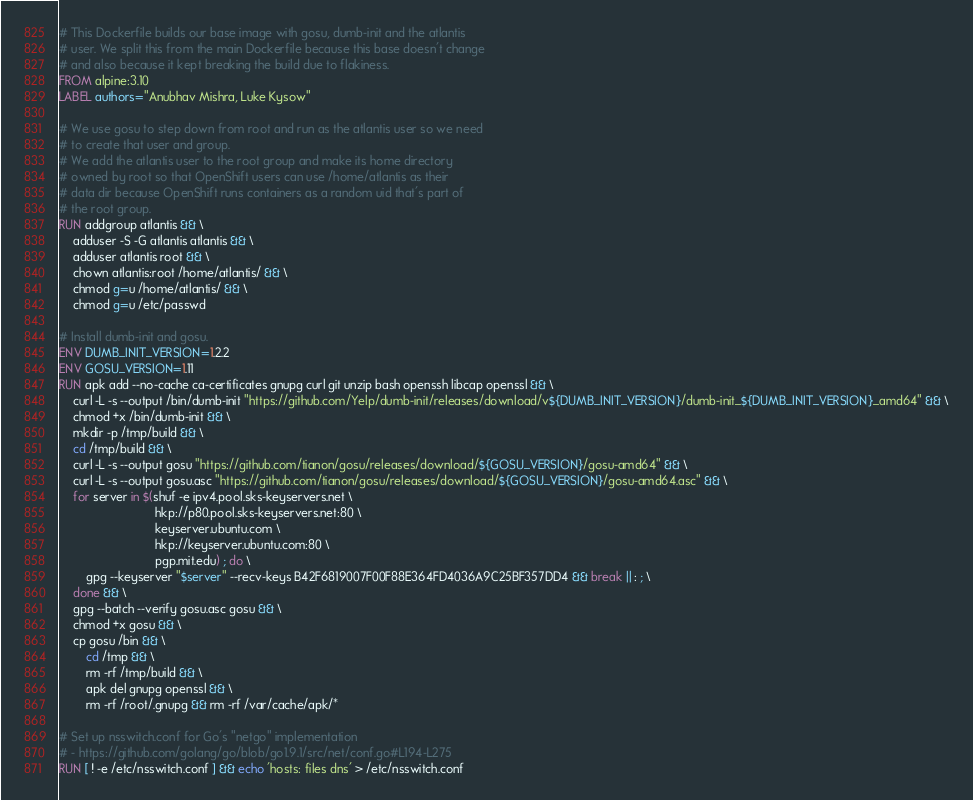Convert code to text. <code><loc_0><loc_0><loc_500><loc_500><_Dockerfile_># This Dockerfile builds our base image with gosu, dumb-init and the atlantis
# user. We split this from the main Dockerfile because this base doesn't change
# and also because it kept breaking the build due to flakiness.
FROM alpine:3.10
LABEL authors="Anubhav Mishra, Luke Kysow"

# We use gosu to step down from root and run as the atlantis user so we need
# to create that user and group.
# We add the atlantis user to the root group and make its home directory
# owned by root so that OpenShift users can use /home/atlantis as their
# data dir because OpenShift runs containers as a random uid that's part of
# the root group.
RUN addgroup atlantis && \
    adduser -S -G atlantis atlantis && \
    adduser atlantis root && \
    chown atlantis:root /home/atlantis/ && \
    chmod g=u /home/atlantis/ && \
    chmod g=u /etc/passwd

# Install dumb-init and gosu.
ENV DUMB_INIT_VERSION=1.2.2
ENV GOSU_VERSION=1.11
RUN apk add --no-cache ca-certificates gnupg curl git unzip bash openssh libcap openssl && \
    curl -L -s --output /bin/dumb-init "https://github.com/Yelp/dumb-init/releases/download/v${DUMB_INIT_VERSION}/dumb-init_${DUMB_INIT_VERSION}_amd64" && \
    chmod +x /bin/dumb-init && \
    mkdir -p /tmp/build && \
    cd /tmp/build && \
    curl -L -s --output gosu "https://github.com/tianon/gosu/releases/download/${GOSU_VERSION}/gosu-amd64" && \
    curl -L -s --output gosu.asc "https://github.com/tianon/gosu/releases/download/${GOSU_VERSION}/gosu-amd64.asc" && \
    for server in $(shuf -e ipv4.pool.sks-keyservers.net \
                            hkp://p80.pool.sks-keyservers.net:80 \
                            keyserver.ubuntu.com \
                            hkp://keyserver.ubuntu.com:80 \
                            pgp.mit.edu) ; do \
        gpg --keyserver "$server" --recv-keys B42F6819007F00F88E364FD4036A9C25BF357DD4 && break || : ; \
    done && \
    gpg --batch --verify gosu.asc gosu && \
    chmod +x gosu && \
    cp gosu /bin && \
        cd /tmp && \
        rm -rf /tmp/build && \
        apk del gnupg openssl && \
        rm -rf /root/.gnupg && rm -rf /var/cache/apk/*

# Set up nsswitch.conf for Go's "netgo" implementation
# - https://github.com/golang/go/blob/go1.9.1/src/net/conf.go#L194-L275
RUN [ ! -e /etc/nsswitch.conf ] && echo 'hosts: files dns' > /etc/nsswitch.conf
</code> 